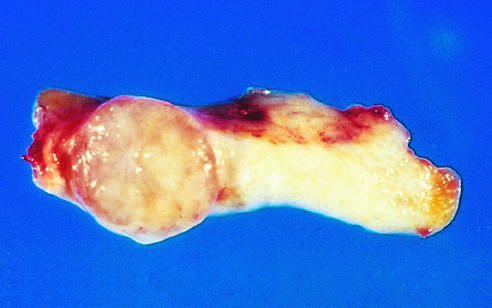what is sharply demarcated from the whiter breast tissue?
Answer the question using a single word or phrase. The tan-colored 